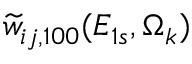Convert formula to latex. <formula><loc_0><loc_0><loc_500><loc_500>\widetilde { w } _ { i j , 1 0 0 } ( E _ { 1 s } , \Omega _ { k } )</formula> 